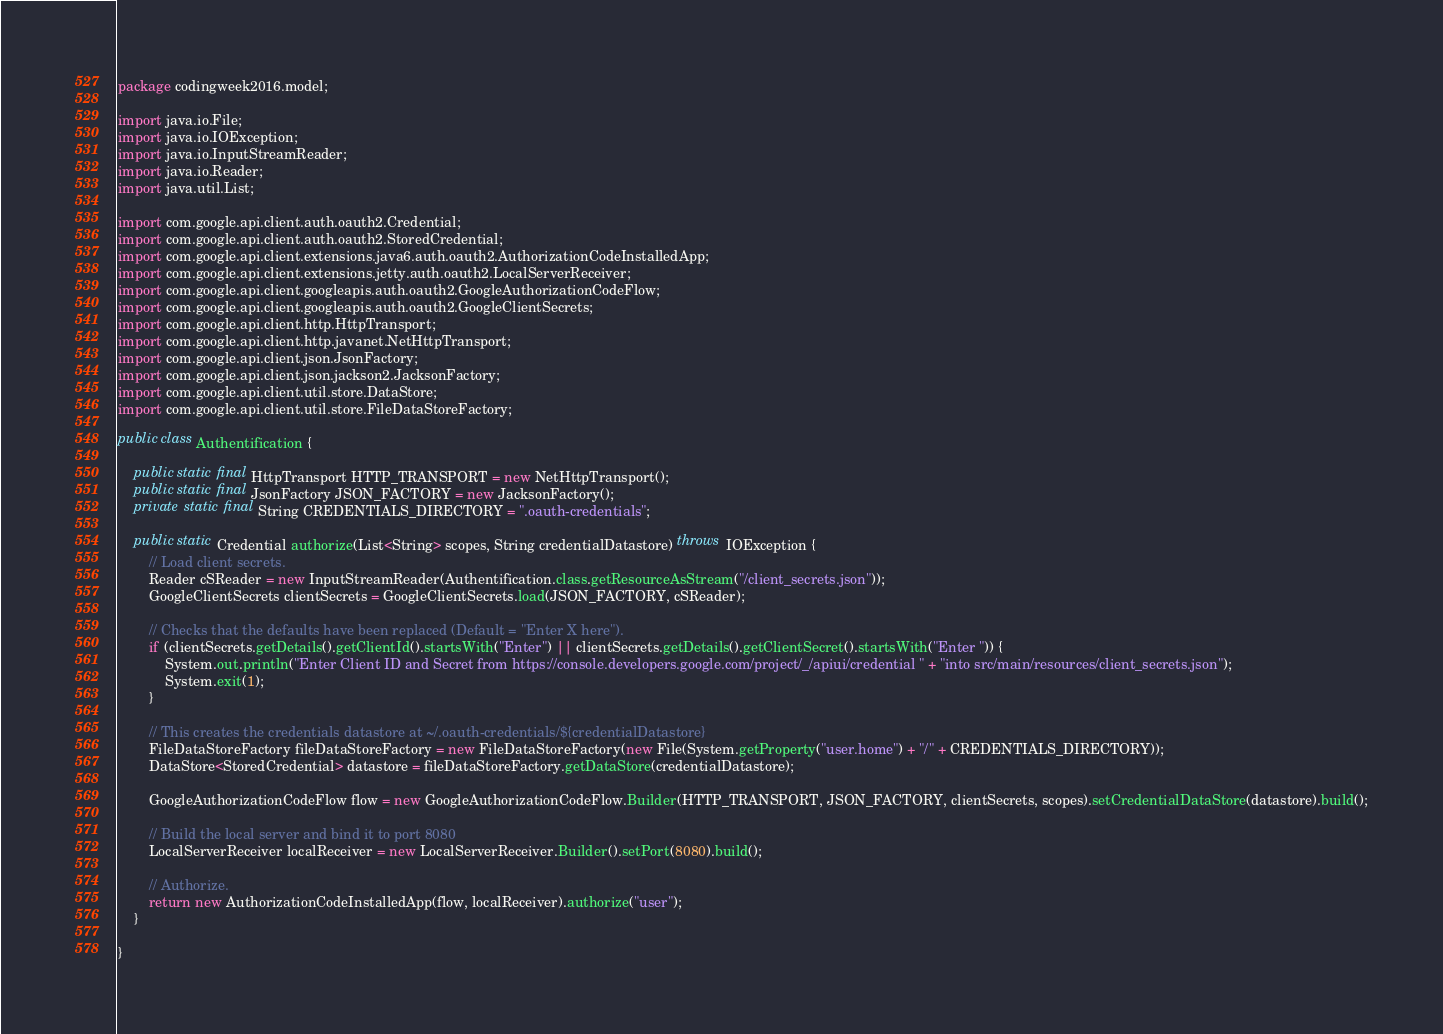Convert code to text. <code><loc_0><loc_0><loc_500><loc_500><_Java_>package codingweek2016.model;

import java.io.File;
import java.io.IOException;
import java.io.InputStreamReader;
import java.io.Reader;
import java.util.List;

import com.google.api.client.auth.oauth2.Credential;
import com.google.api.client.auth.oauth2.StoredCredential;
import com.google.api.client.extensions.java6.auth.oauth2.AuthorizationCodeInstalledApp;
import com.google.api.client.extensions.jetty.auth.oauth2.LocalServerReceiver;
import com.google.api.client.googleapis.auth.oauth2.GoogleAuthorizationCodeFlow;
import com.google.api.client.googleapis.auth.oauth2.GoogleClientSecrets;
import com.google.api.client.http.HttpTransport;
import com.google.api.client.http.javanet.NetHttpTransport;
import com.google.api.client.json.JsonFactory;
import com.google.api.client.json.jackson2.JacksonFactory;
import com.google.api.client.util.store.DataStore;
import com.google.api.client.util.store.FileDataStoreFactory;

public class Authentification {
	
	public static final HttpTransport HTTP_TRANSPORT = new NetHttpTransport();
    public static final JsonFactory JSON_FACTORY = new JacksonFactory();
    private static final String CREDENTIALS_DIRECTORY = ".oauth-credentials";
    
    public static Credential authorize(List<String> scopes, String credentialDatastore) throws IOException {
    	// Load client secrets.
        Reader cSReader = new InputStreamReader(Authentification.class.getResourceAsStream("/client_secrets.json"));
        GoogleClientSecrets clientSecrets = GoogleClientSecrets.load(JSON_FACTORY, cSReader);

        // Checks that the defaults have been replaced (Default = "Enter X here").
        if (clientSecrets.getDetails().getClientId().startsWith("Enter") || clientSecrets.getDetails().getClientSecret().startsWith("Enter ")) {
            System.out.println("Enter Client ID and Secret from https://console.developers.google.com/project/_/apiui/credential " + "into src/main/resources/client_secrets.json");
            System.exit(1);
        }

        // This creates the credentials datastore at ~/.oauth-credentials/${credentialDatastore}
        FileDataStoreFactory fileDataStoreFactory = new FileDataStoreFactory(new File(System.getProperty("user.home") + "/" + CREDENTIALS_DIRECTORY));
        DataStore<StoredCredential> datastore = fileDataStoreFactory.getDataStore(credentialDatastore);

        GoogleAuthorizationCodeFlow flow = new GoogleAuthorizationCodeFlow.Builder(HTTP_TRANSPORT, JSON_FACTORY, clientSecrets, scopes).setCredentialDataStore(datastore).build();

        // Build the local server and bind it to port 8080
        LocalServerReceiver localReceiver = new LocalServerReceiver.Builder().setPort(8080).build();

        // Authorize.
        return new AuthorizationCodeInstalledApp(flow, localReceiver).authorize("user");
    }

}
</code> 